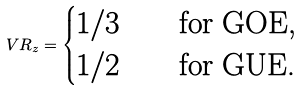Convert formula to latex. <formula><loc_0><loc_0><loc_500><loc_500>V R _ { z } = \begin{cases} 1 / 3 & \quad \text {for GOE, } \\ 1 / 2 & \quad \text {for GUE. } \end{cases}</formula> 